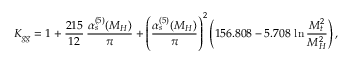<formula> <loc_0><loc_0><loc_500><loc_500>K _ { g g } = 1 + \frac { 2 1 5 } { 1 2 } \, \frac { \alpha _ { s } ^ { ( 5 ) } ( M _ { H } ) } { \pi } + \left ( \frac { \alpha _ { s } ^ { ( 5 ) } ( M _ { H } ) } { \pi } \right ) ^ { 2 } \left ( 1 5 6 . 8 0 8 - 5 . 7 0 8 \, \ln \frac { M _ { t } ^ { 2 } } { M _ { H } ^ { 2 } } \right ) ,</formula> 